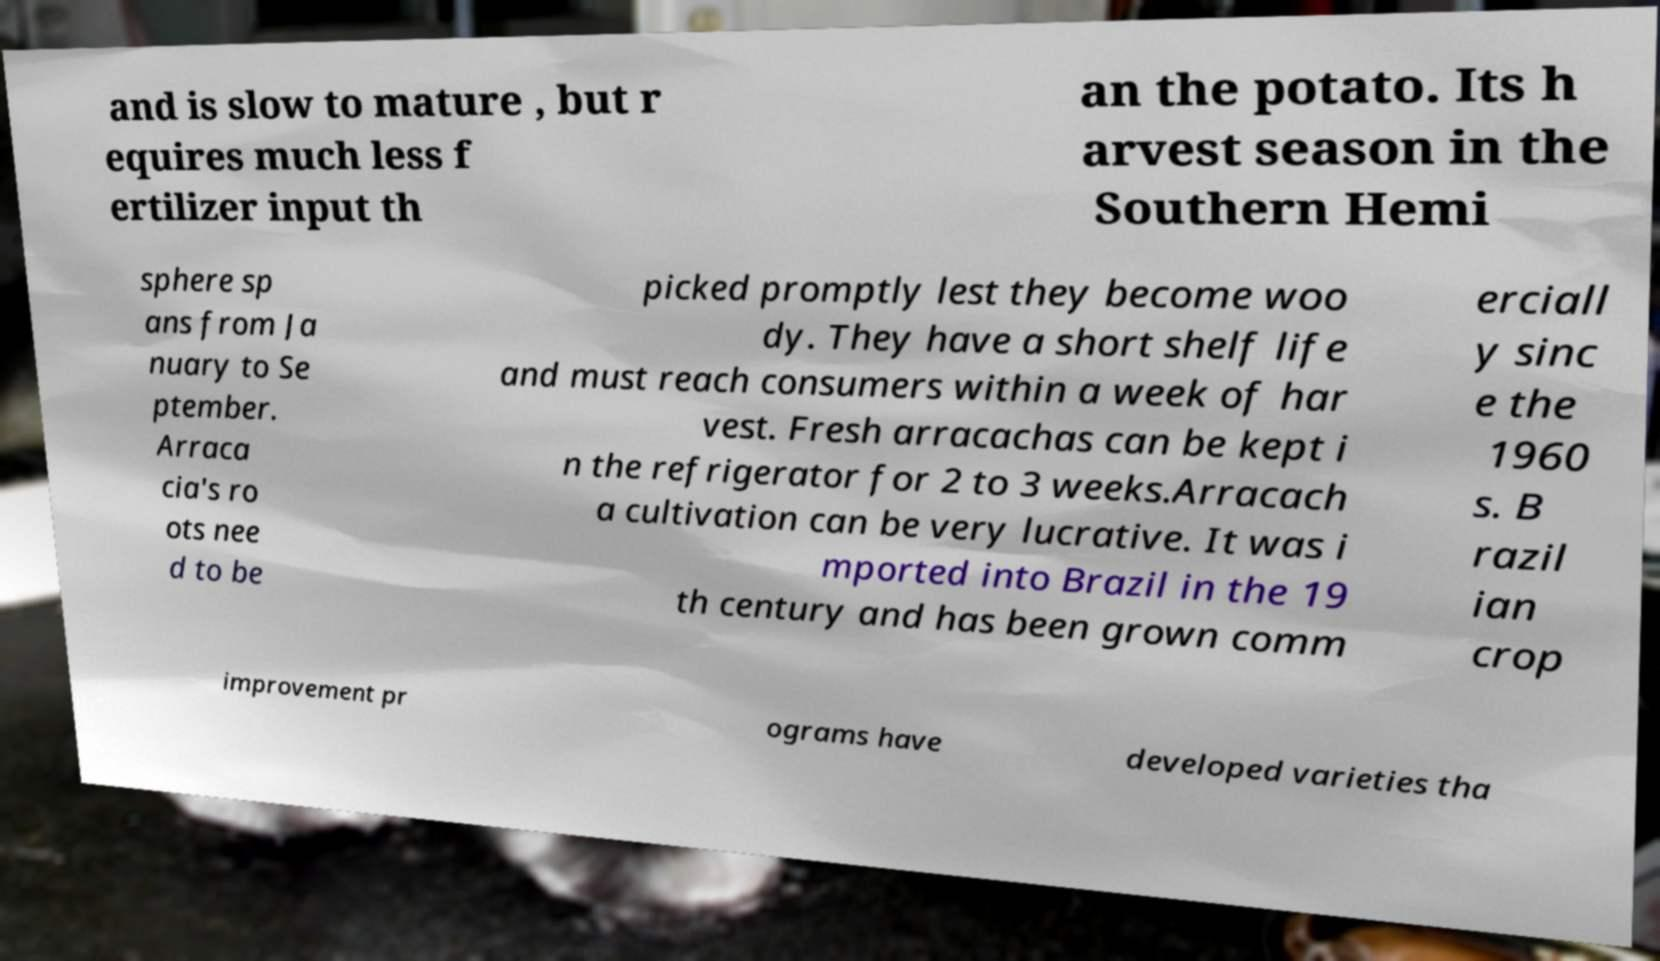Could you assist in decoding the text presented in this image and type it out clearly? and is slow to mature , but r equires much less f ertilizer input th an the potato. Its h arvest season in the Southern Hemi sphere sp ans from Ja nuary to Se ptember. Arraca cia's ro ots nee d to be picked promptly lest they become woo dy. They have a short shelf life and must reach consumers within a week of har vest. Fresh arracachas can be kept i n the refrigerator for 2 to 3 weeks.Arracach a cultivation can be very lucrative. It was i mported into Brazil in the 19 th century and has been grown comm erciall y sinc e the 1960 s. B razil ian crop improvement pr ograms have developed varieties tha 